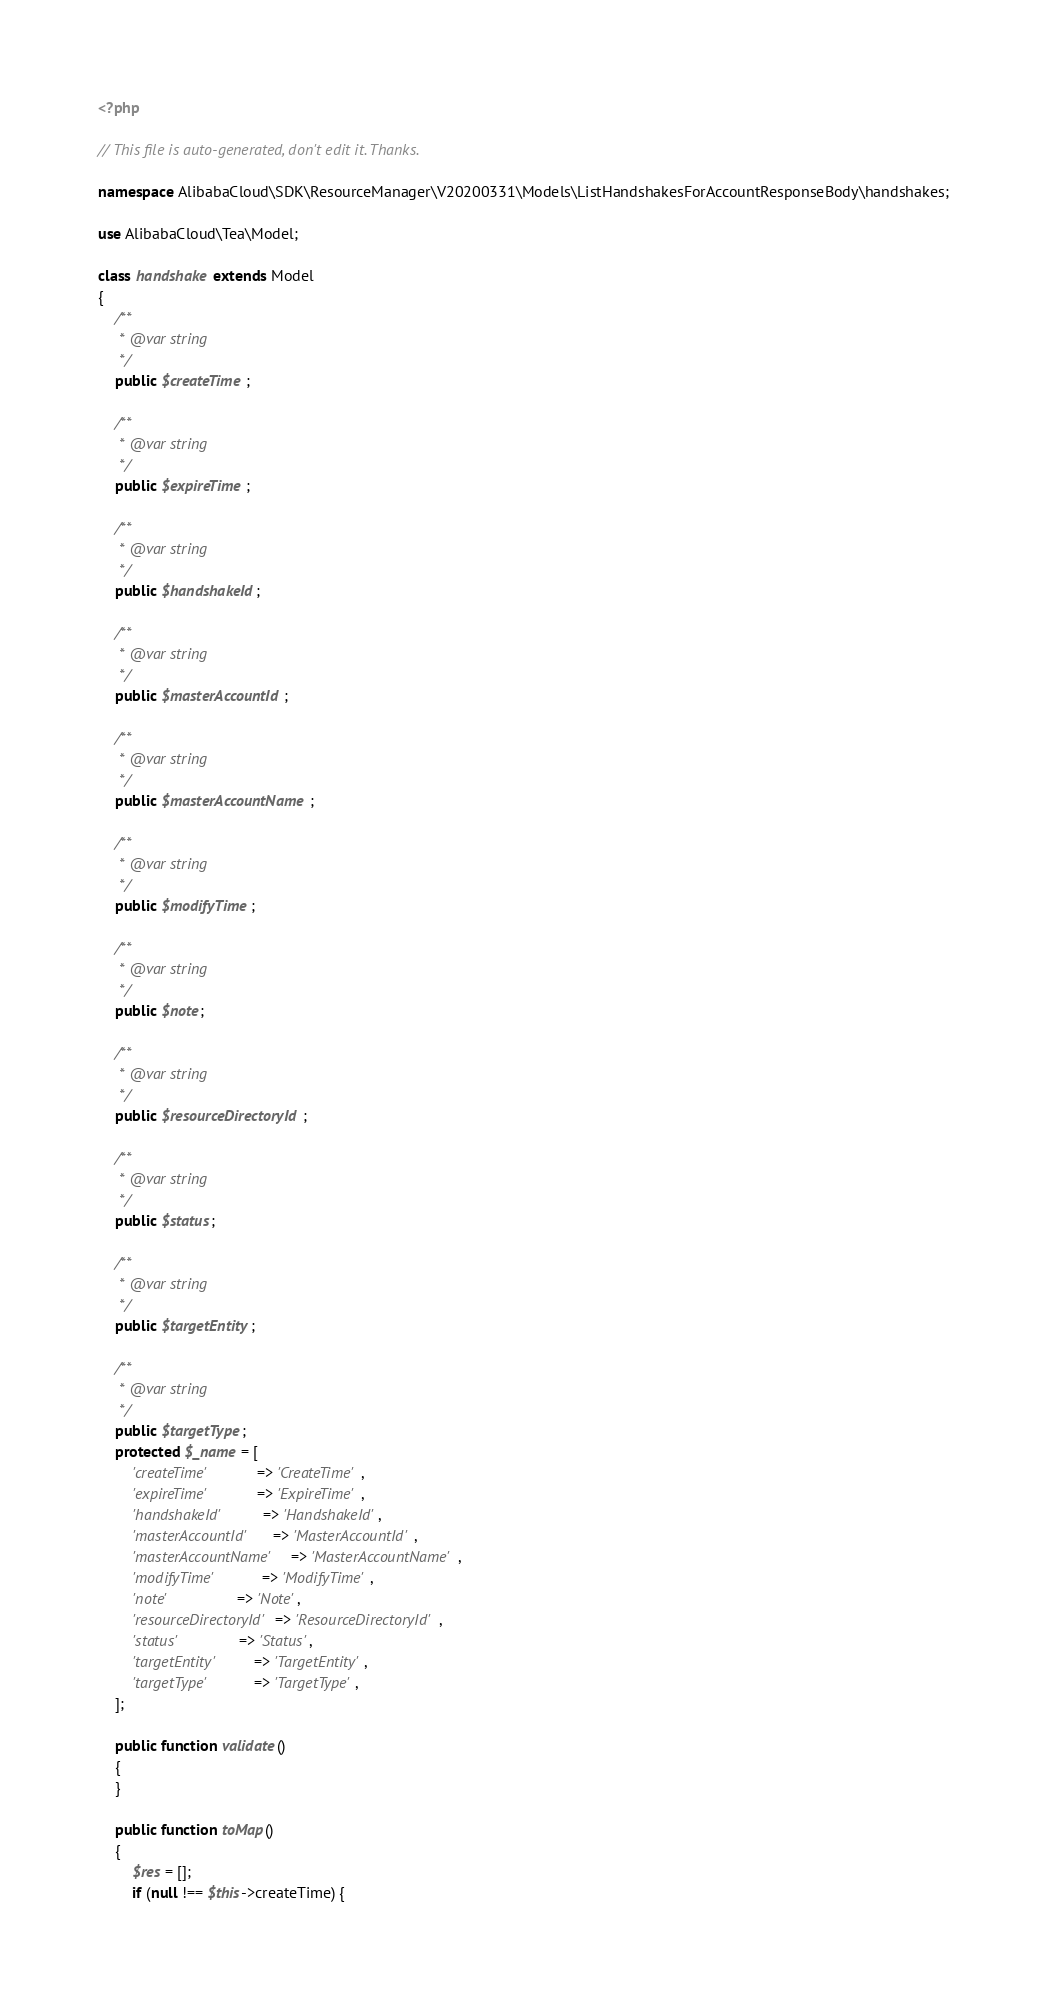<code> <loc_0><loc_0><loc_500><loc_500><_PHP_><?php

// This file is auto-generated, don't edit it. Thanks.

namespace AlibabaCloud\SDK\ResourceManager\V20200331\Models\ListHandshakesForAccountResponseBody\handshakes;

use AlibabaCloud\Tea\Model;

class handshake extends Model
{
    /**
     * @var string
     */
    public $createTime;

    /**
     * @var string
     */
    public $expireTime;

    /**
     * @var string
     */
    public $handshakeId;

    /**
     * @var string
     */
    public $masterAccountId;

    /**
     * @var string
     */
    public $masterAccountName;

    /**
     * @var string
     */
    public $modifyTime;

    /**
     * @var string
     */
    public $note;

    /**
     * @var string
     */
    public $resourceDirectoryId;

    /**
     * @var string
     */
    public $status;

    /**
     * @var string
     */
    public $targetEntity;

    /**
     * @var string
     */
    public $targetType;
    protected $_name = [
        'createTime'          => 'CreateTime',
        'expireTime'          => 'ExpireTime',
        'handshakeId'         => 'HandshakeId',
        'masterAccountId'     => 'MasterAccountId',
        'masterAccountName'   => 'MasterAccountName',
        'modifyTime'          => 'ModifyTime',
        'note'                => 'Note',
        'resourceDirectoryId' => 'ResourceDirectoryId',
        'status'              => 'Status',
        'targetEntity'        => 'TargetEntity',
        'targetType'          => 'TargetType',
    ];

    public function validate()
    {
    }

    public function toMap()
    {
        $res = [];
        if (null !== $this->createTime) {</code> 